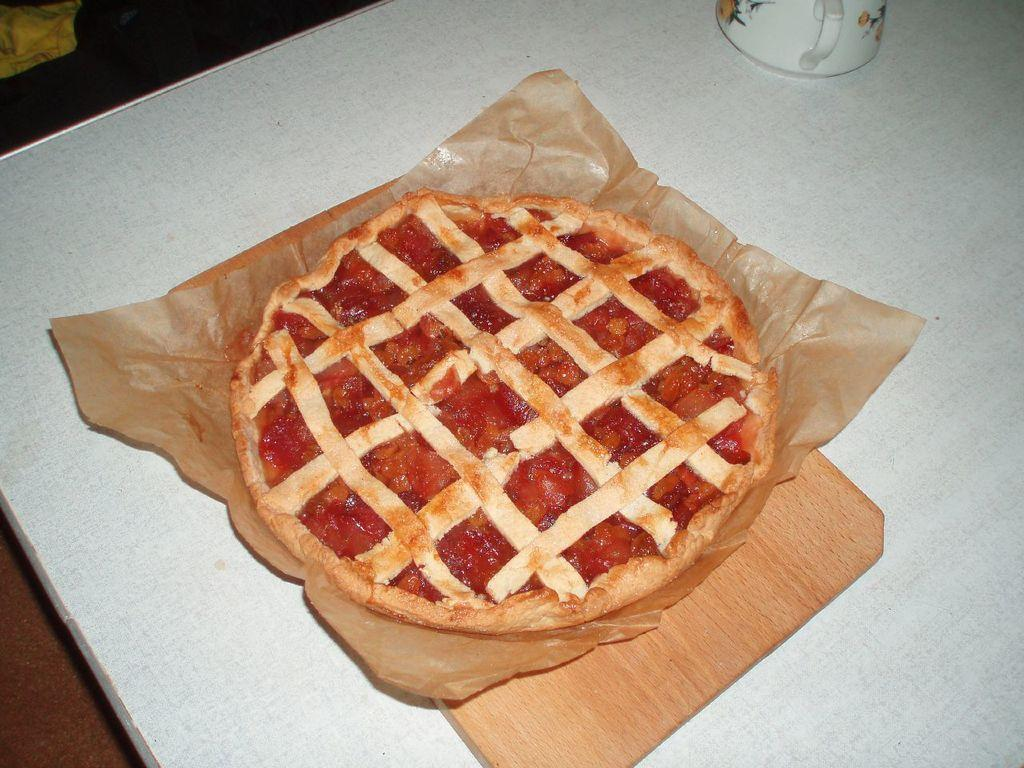What is on the wooden plate in the image? There is a food item on a wooden plate in the image. What else can be seen on the table in the image? There is a cup on the table in the image. What is at the bottom of the image? There is a mat at the bottom of the image. What type of drug is being used to create shade in the image? There is no drug or shade present in the image. What government policy is being discussed in the image? There is no discussion of government policy in the image. 